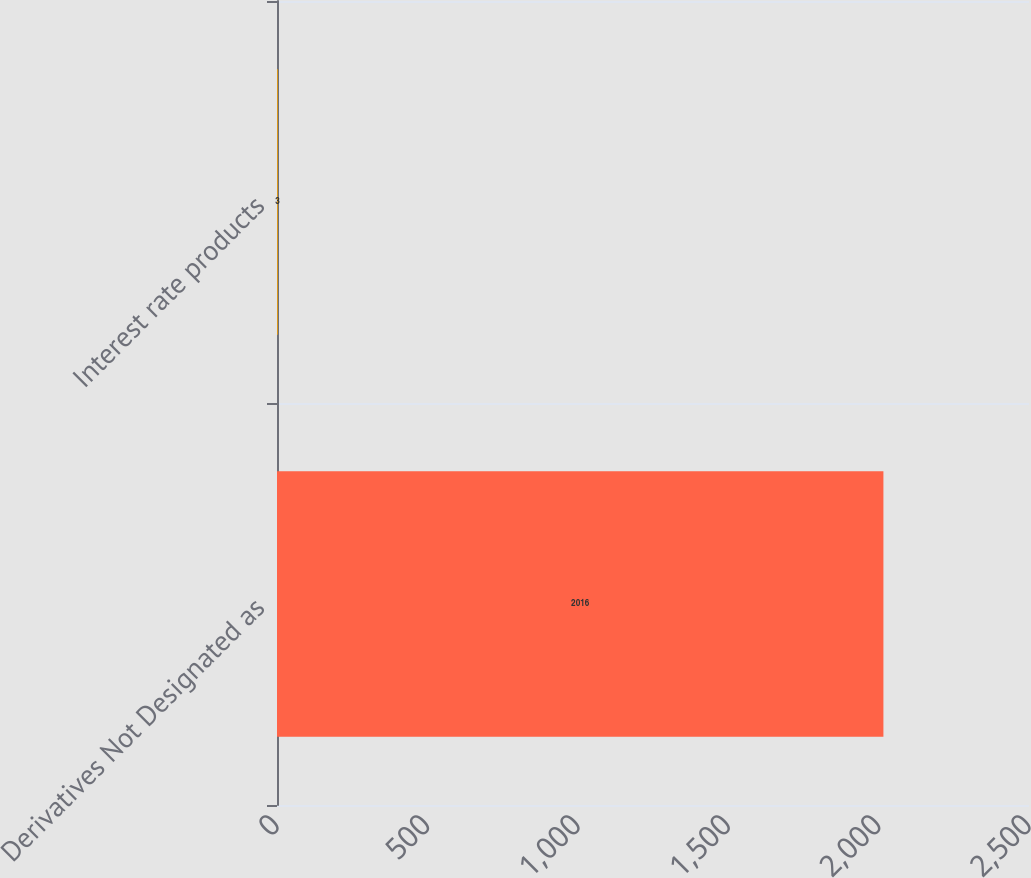Convert chart. <chart><loc_0><loc_0><loc_500><loc_500><bar_chart><fcel>Derivatives Not Designated as<fcel>Interest rate products<nl><fcel>2016<fcel>3<nl></chart> 